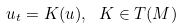<formula> <loc_0><loc_0><loc_500><loc_500>u _ { t } = K ( u ) , \ K \in T ( M )</formula> 